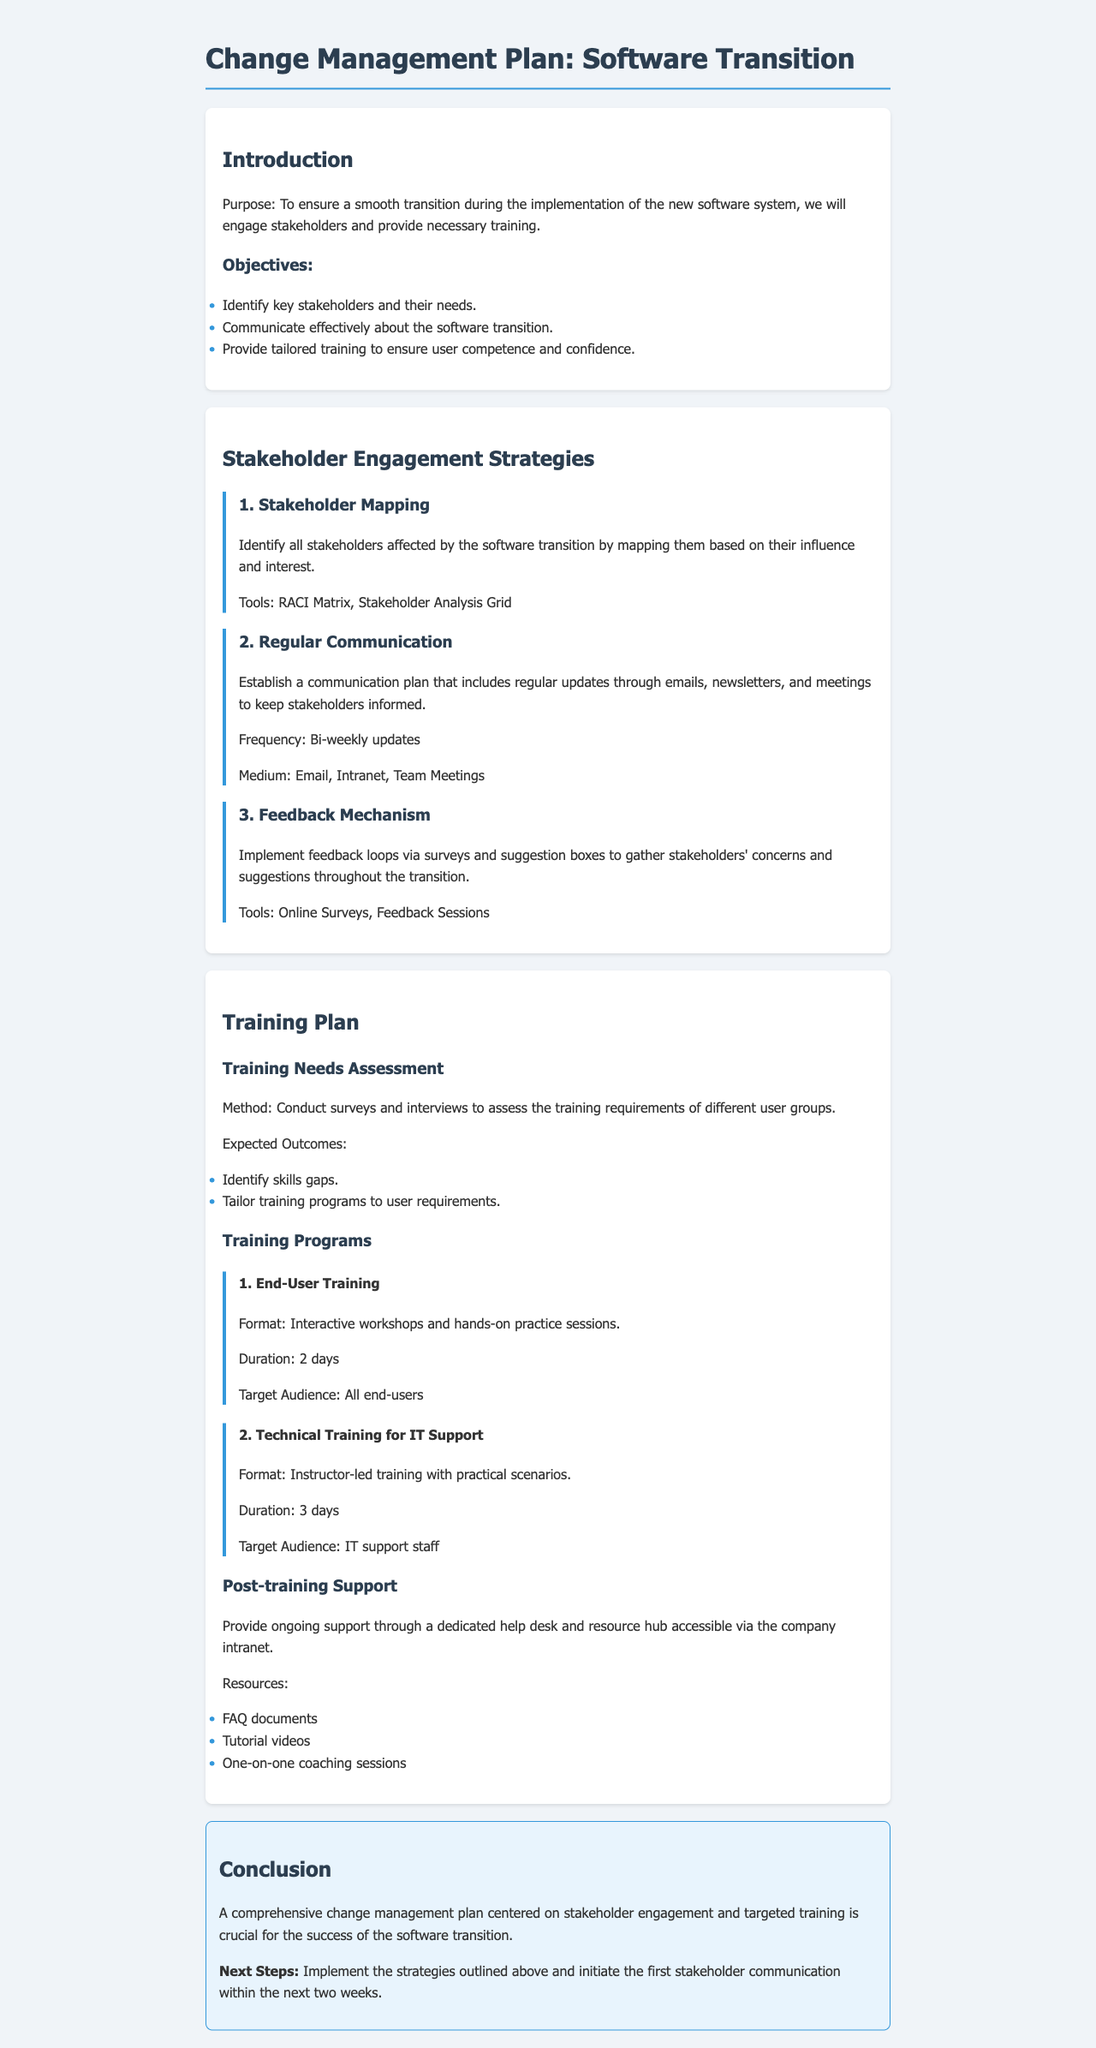what is the purpose of the change management plan? The purpose is to ensure a smooth transition during the implementation of the new software system.
Answer: To ensure a smooth transition during the implementation of the new software system what tool is mentioned for stakeholder mapping? The document mentions tools used in stakeholder mapping.
Answer: RACI Matrix, Stakeholder Analysis Grid how often will stakeholders receive updates? The document specifies the frequency of updates for stakeholders.
Answer: Bi-weekly updates what format is used for End-User Training? The document describes the training format for End-User Training.
Answer: Interactive workshops and hands-on practice sessions what is the expected outcome of the training needs assessment? The document outlines one of the expected outcomes of the training needs assessment.
Answer: Identify skills gaps what support will be provided post-training? The document details the type of support available after training.
Answer: Ongoing support through a dedicated help desk and resource hub what is the duration of the Technical Training for IT Support? The document provides the duration for the Technical Training course.
Answer: 3 days what is the next step mentioned in the conclusion? The document states the next steps to be taken after the plan is concluded.
Answer: Implement the strategies outlined above and initiate the first stakeholder communication within the next two weeks 